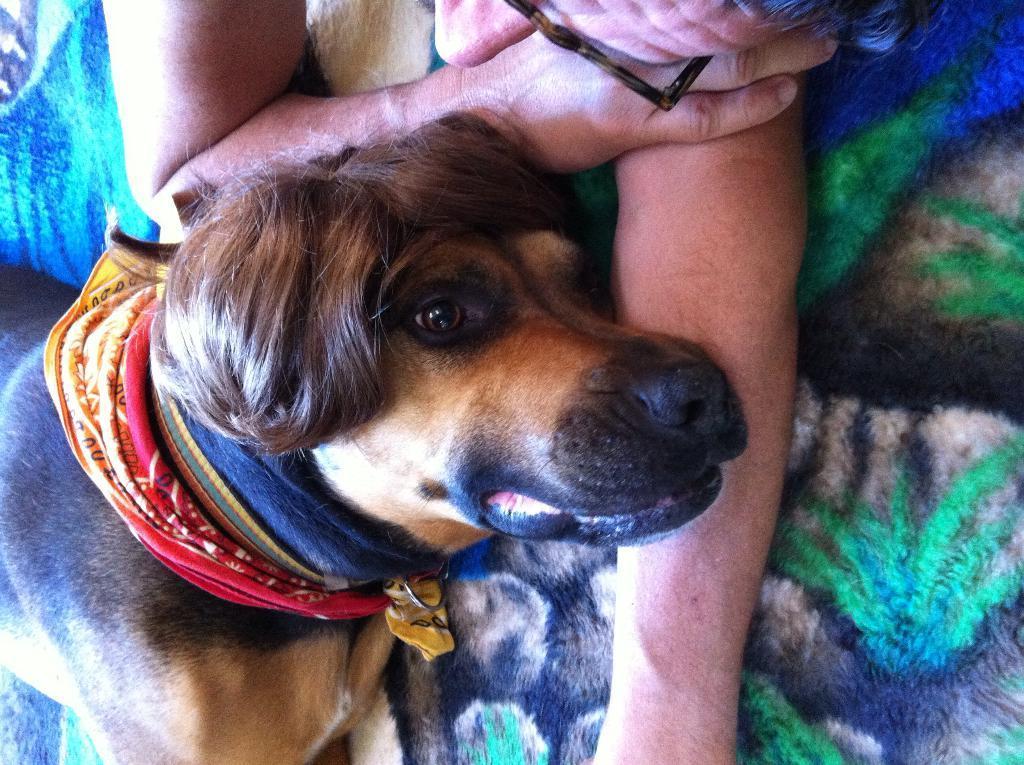Could you give a brief overview of what you see in this image? In this image I can see a dog which is in brown color, background I can see a person laying on the blue and green color surface. 